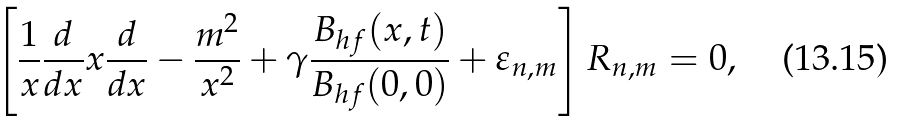Convert formula to latex. <formula><loc_0><loc_0><loc_500><loc_500>\left [ \frac { 1 } { x } \frac { d } { d x } x \frac { d } { d x } - \frac { m ^ { 2 } } { x ^ { 2 } } + \gamma \frac { B _ { h f } ( x , t ) } { B _ { h f } ( 0 , 0 ) } + \varepsilon _ { n , m } \right ] R _ { n , m } = 0 ,</formula> 